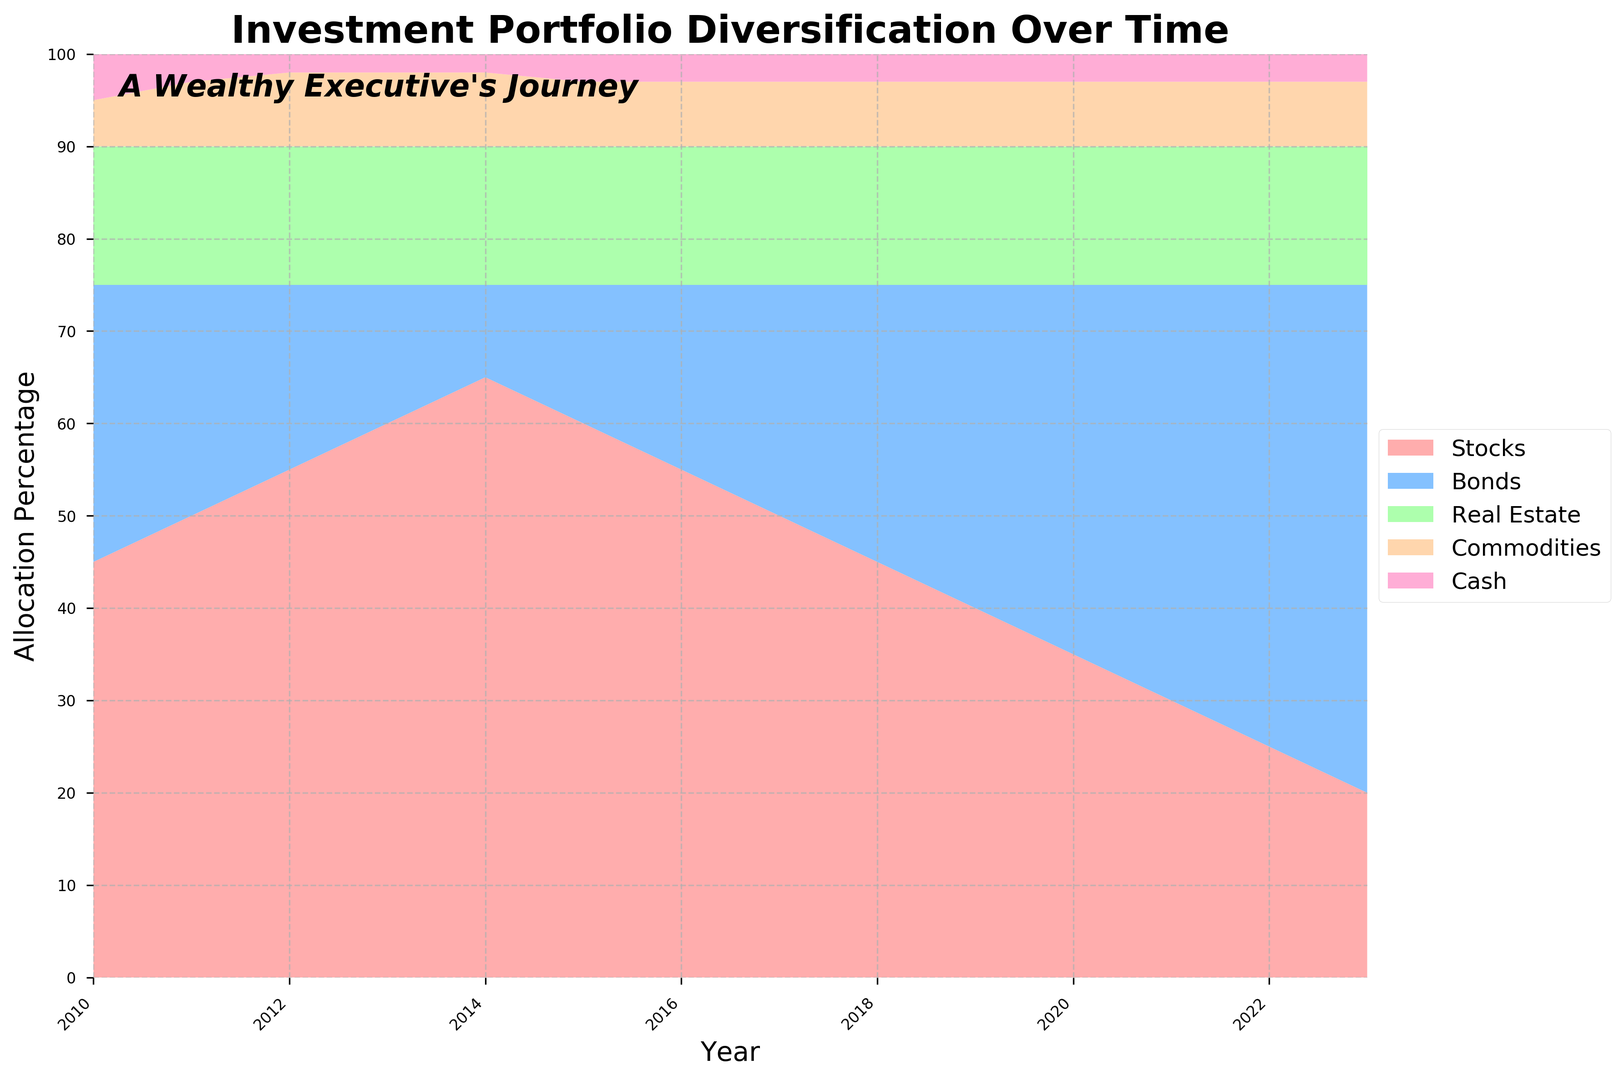What's the dominant asset class by 2023? In 2023, the stack plot shows that Bonds occupy the largest section of the area, indicating they are the dominant asset class.
Answer: Bonds How has the allocation to Stocks changed from 2010 to 2023? In 2010, the allocation to Stocks was at 45%. By 2023, it decreased progressively to 20%. This shows a significant decrease over time.
Answer: Decreased When does the allocation to Bonds surpass that to Stocks? Adding the data from various years, we see that in 2020, Bonds surpass Stocks for the first time as Bonds are 40% and Stocks are 35%.
Answer: 2020 What's the total allocation to Real Estate over these years? Real Estate maintains a constant allocation of 15% every year from 2010 to 2023. To find the total, multiply 15 by the number of years, 14 (15 * 14).
Answer: 210% Which asset class allocation remains constant throughout all years? The allocation to Real Estate holds steady at 15% from 2010 to 2023 as seen from the consistent area in the stack plot.
Answer: Real Estate What is the average allocation percentage to Commodities from 2010 to 2023? The allocation to Commodities is 5% in 2010, 7% in 2011 and 2012, and 8% from 2013 onwards. Calculate the average over the 14 years: (5 + 7 + 7 + 8*11) / 14.
Answer: 7.86% In which year is the allocation to Bonds equal to the allocation to Stocks? From the plot, 2021 is the year Bonds and Stocks have equal allocation, both at 30%.
Answer: 2021 How does the area representing Cash change over time? From the start to the end, the Cash allocation shows minor changes, starting at 5% in 2010, dropping to 2% in 2012, and stabilizing at 3% from 2015 onwards.
Answer: Slightly decreased What's the difference in Stocks allocation between 2010 and 2023? In 2010, the allocation to Stocks was at 45%. By 2023, it decreased to 20%. The difference is 45% - 20%.
Answer: 25% During which years does the allocation to Bonds consistently increase? From the stack plot, the allocation to Bonds increases consistently from 2016 to 2023.
Answer: 2016-2023 